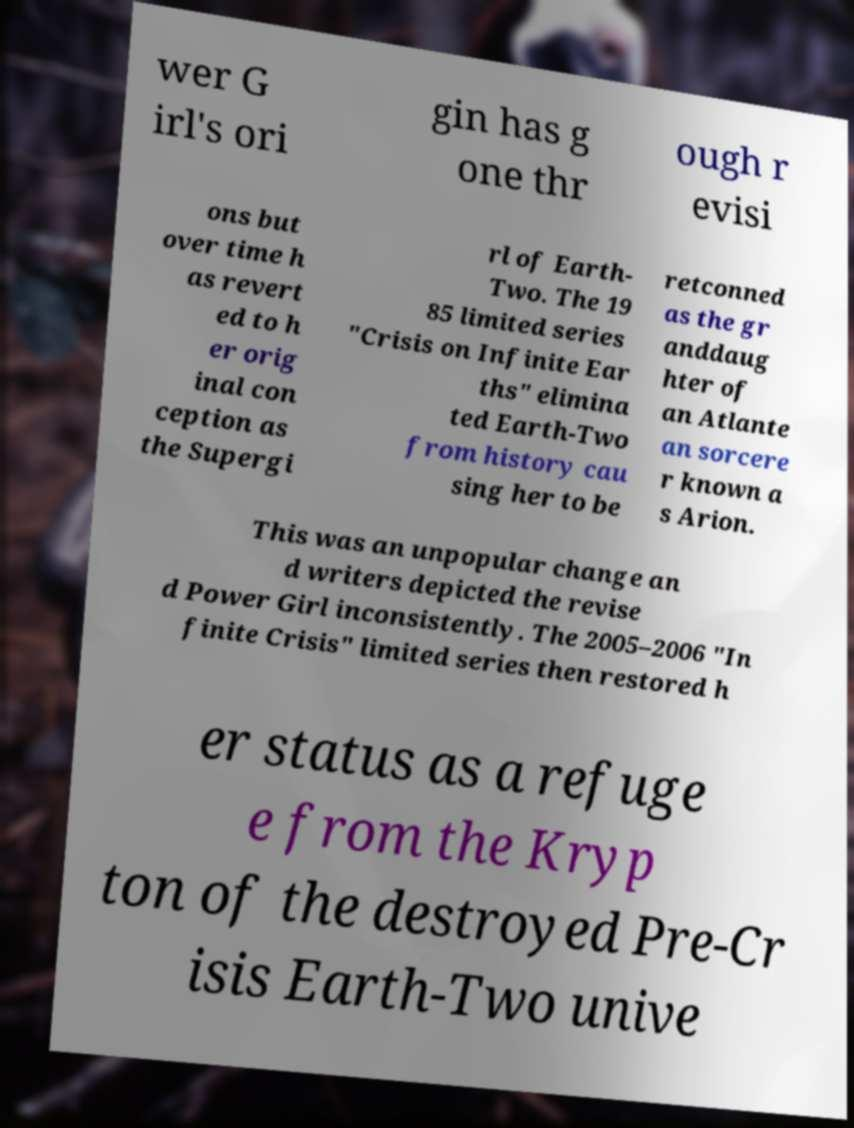For documentation purposes, I need the text within this image transcribed. Could you provide that? wer G irl's ori gin has g one thr ough r evisi ons but over time h as revert ed to h er orig inal con ception as the Supergi rl of Earth- Two. The 19 85 limited series "Crisis on Infinite Ear ths" elimina ted Earth-Two from history cau sing her to be retconned as the gr anddaug hter of an Atlante an sorcere r known a s Arion. This was an unpopular change an d writers depicted the revise d Power Girl inconsistently. The 2005–2006 "In finite Crisis" limited series then restored h er status as a refuge e from the Kryp ton of the destroyed Pre-Cr isis Earth-Two unive 